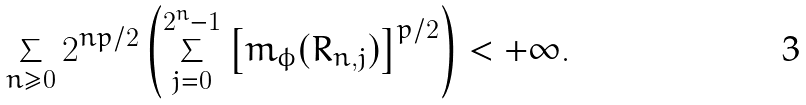<formula> <loc_0><loc_0><loc_500><loc_500>\sum _ { n \geq 0 } 2 ^ { n p / 2 } \left ( \sum _ { j = 0 } ^ { 2 ^ { n } - 1 } \left [ m _ { \phi } ( R _ { n , j } ) \right ] ^ { p / 2 } \right ) < + \infty .</formula> 